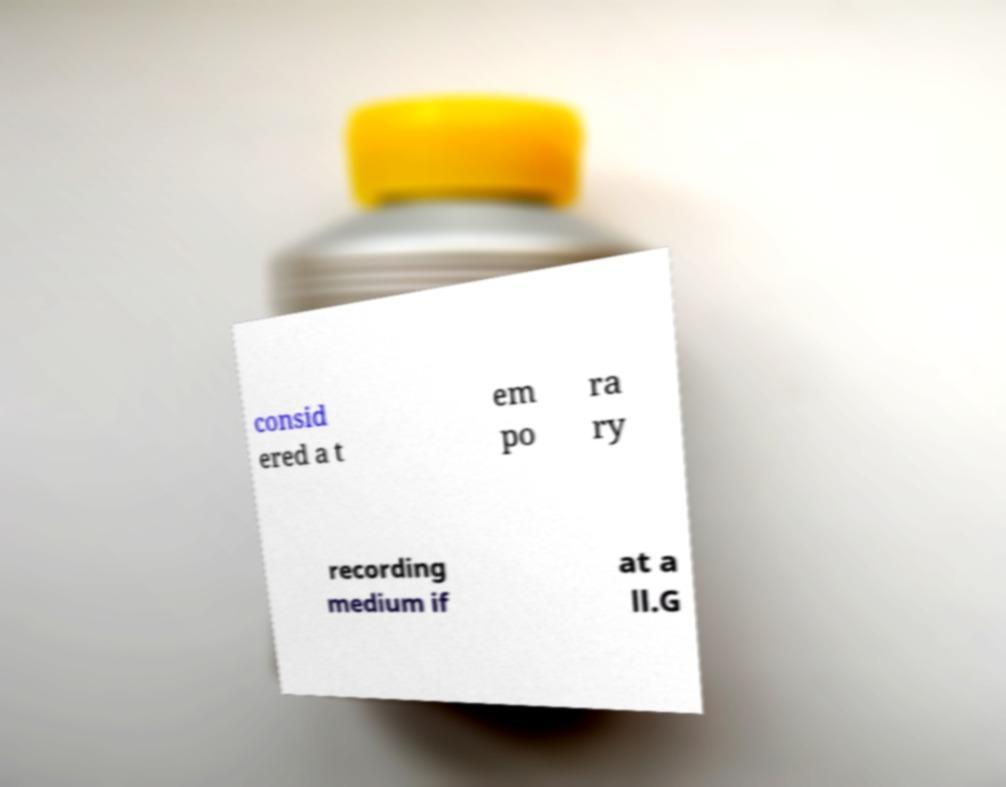Could you extract and type out the text from this image? consid ered a t em po ra ry recording medium if at a ll.G 